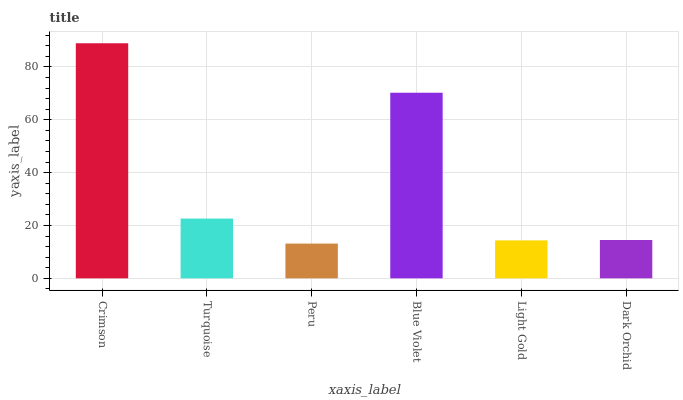Is Peru the minimum?
Answer yes or no. Yes. Is Crimson the maximum?
Answer yes or no. Yes. Is Turquoise the minimum?
Answer yes or no. No. Is Turquoise the maximum?
Answer yes or no. No. Is Crimson greater than Turquoise?
Answer yes or no. Yes. Is Turquoise less than Crimson?
Answer yes or no. Yes. Is Turquoise greater than Crimson?
Answer yes or no. No. Is Crimson less than Turquoise?
Answer yes or no. No. Is Turquoise the high median?
Answer yes or no. Yes. Is Dark Orchid the low median?
Answer yes or no. Yes. Is Crimson the high median?
Answer yes or no. No. Is Crimson the low median?
Answer yes or no. No. 